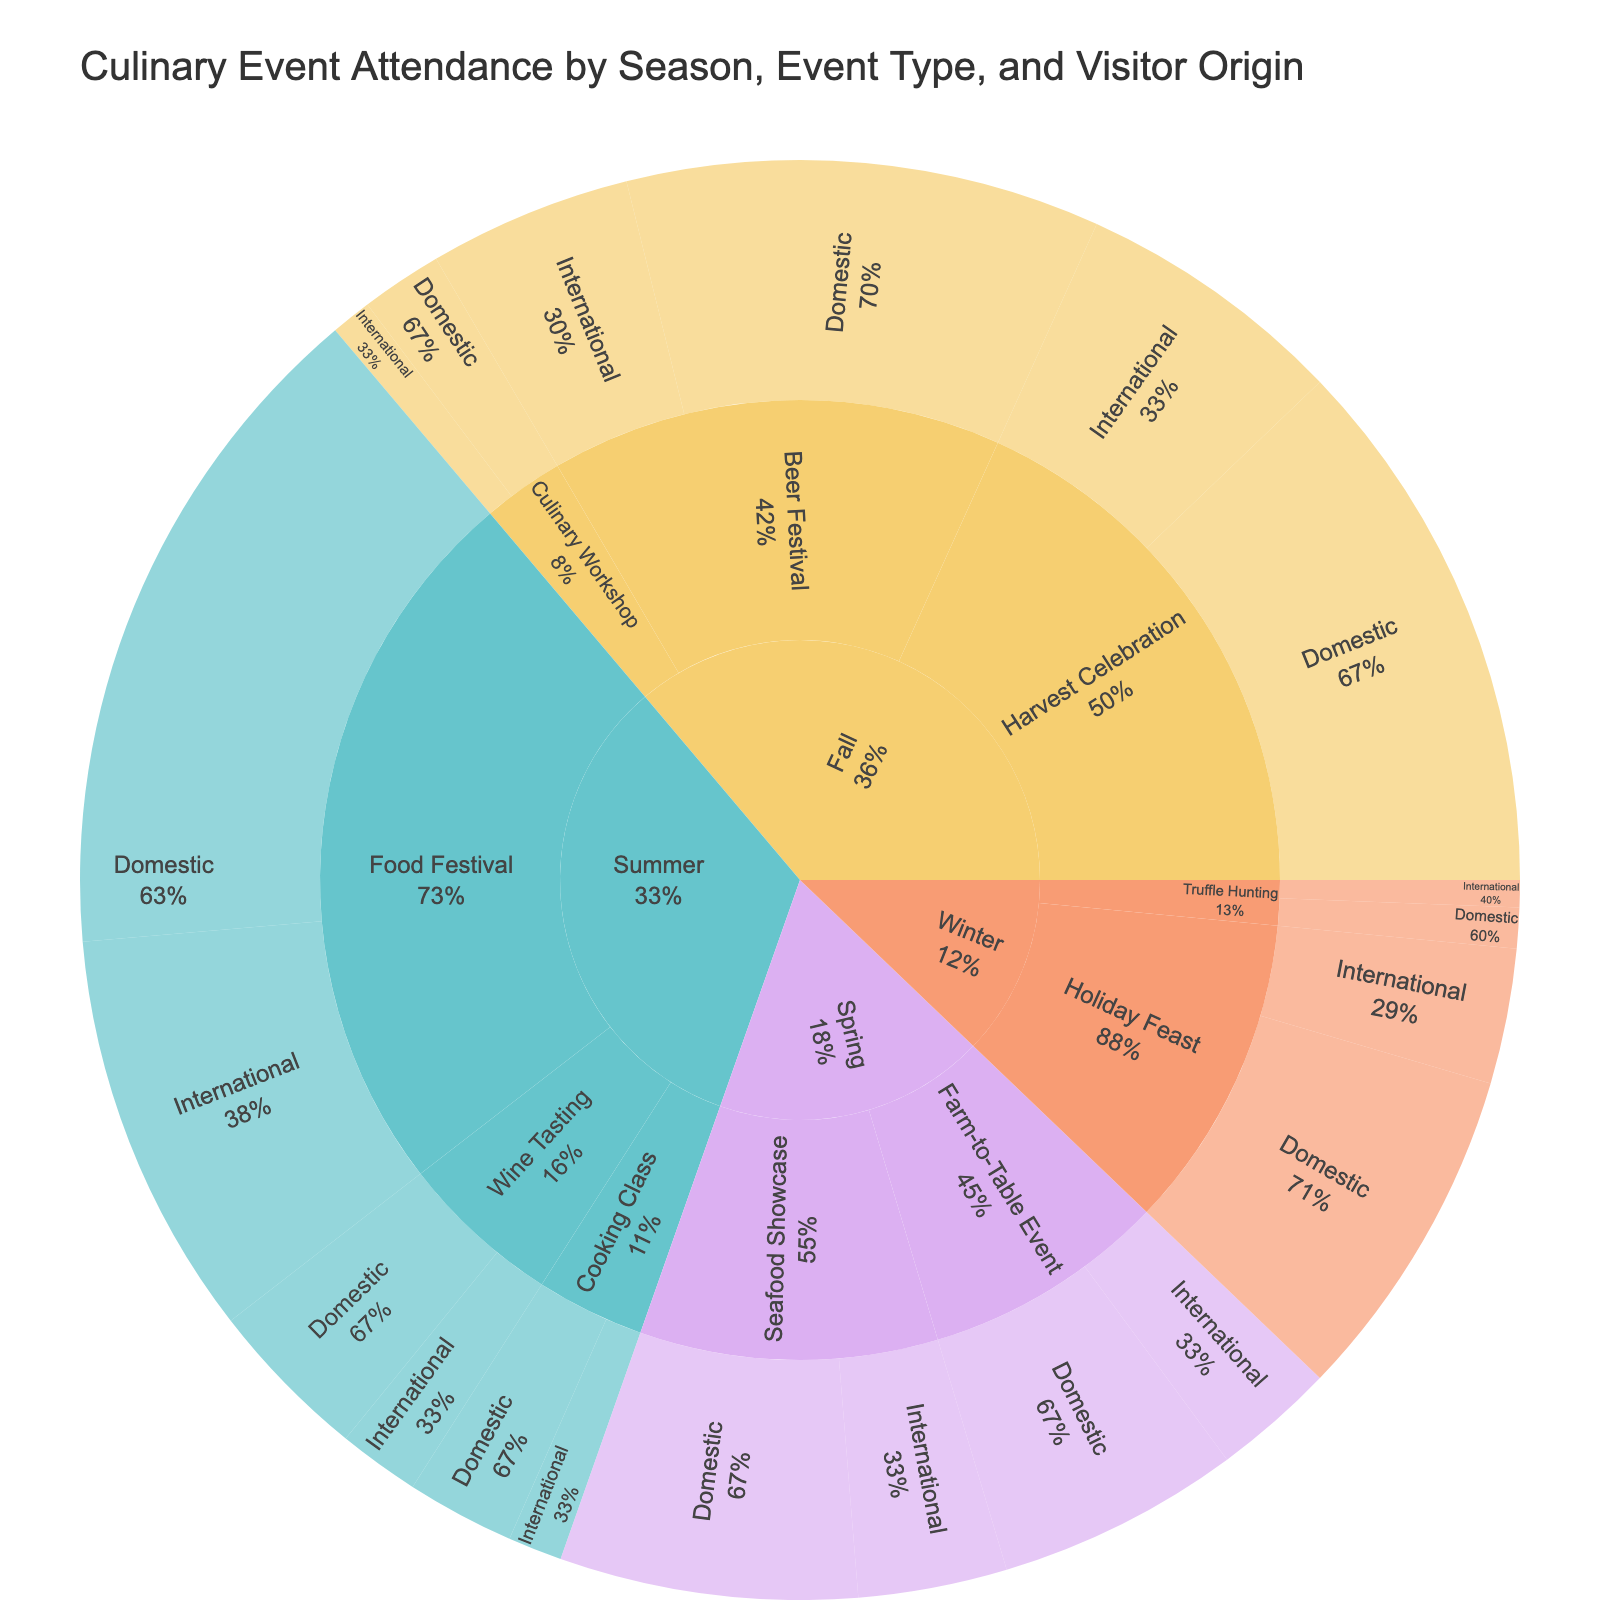What season has the highest total attendance? To find the season with the highest total attendance, identify all categories within each season and sum their attendances. Summer has the highest total attendance because the attendances for all events sum up to 11000.
Answer: Summer How does domestic attendance compare to international attendance for the Food Festivals in Summer? In Summer, the domestic attendance for Food Festivals is 5000, and the international attendance is 3000. Comparing these figures, domestic attendance is higher than international attendance.
Answer: Domestic attendance is higher What is the total attendance for Wine Tasting events across all seasons? To find the total attendance for Wine Tasting events, sum up the attendances across all related categories. In the Summer: Domestic (1200) + International (600) = 1800. The total attendance for Wine Tasting events is 1800.
Answer: 1800 Which event type within Fall has the lowest attendance, and what is its value? For Fall, identify the attendance for all event types: Harvest Celebration (6000), Culinary Workshop (900), and Beer Festival (5000). Culinary Workshop has the lowest attendance with a total of 900.
Answer: Culinary Workshop with 900 What percentage of Spring’s attendance is from international visitors? To determine the percentage, sum up Spring's total attendance (1800 + 900 + 2200 + 1100 = 6000) and international attendance (900 + 1100 = 2000). The percentage is calculated as (2000 / 6000) * 100 = 33.3%.
Answer: 33.3% What's the most popular event type in terms of total attendance? Determine the total attendance for each event type across all seasons and compare. Food Festivals in Summer have the highest total attendance (5000 + 3000 = 8000).
Answer: Food Festivals Which season has the least international attendance, and what is its value? Identify each season's international attendance: Summer (4000), Fall (3800), Winter (1200), Spring (2000). Winter has the least international attendance with a value of 1200.
Answer: Winter with 1200 For which event type is the domestic attendance almost twice the international attendance in Fall, and what are the figures? In Fall, compare domestic and international attendances of all event types. Beer Festival: Domestic (3500), International (1500). Here, the domestic attendance is almost twice the international attendance (3500 ≈ 2*1500).
Answer: Beer Festival, Domestic: 3500, International: 1500 How does attendance for Cooking Classes in Summer compare between domestic and international visitors? For Cooking Classes in Summer, the domestic attendance is 800 and the international attendance is 400. The domestic attendance is twice the international attendance.
Answer: Domestic attendance is twice Which event has more international visitors in Winter, Holiday Feast or Truffle Hunting? In Winter, compare the international attendances for Holiday Feast (1000) and Truffle Hunting (200). Holiday Feast has more international visitors.
Answer: Holiday Feast 